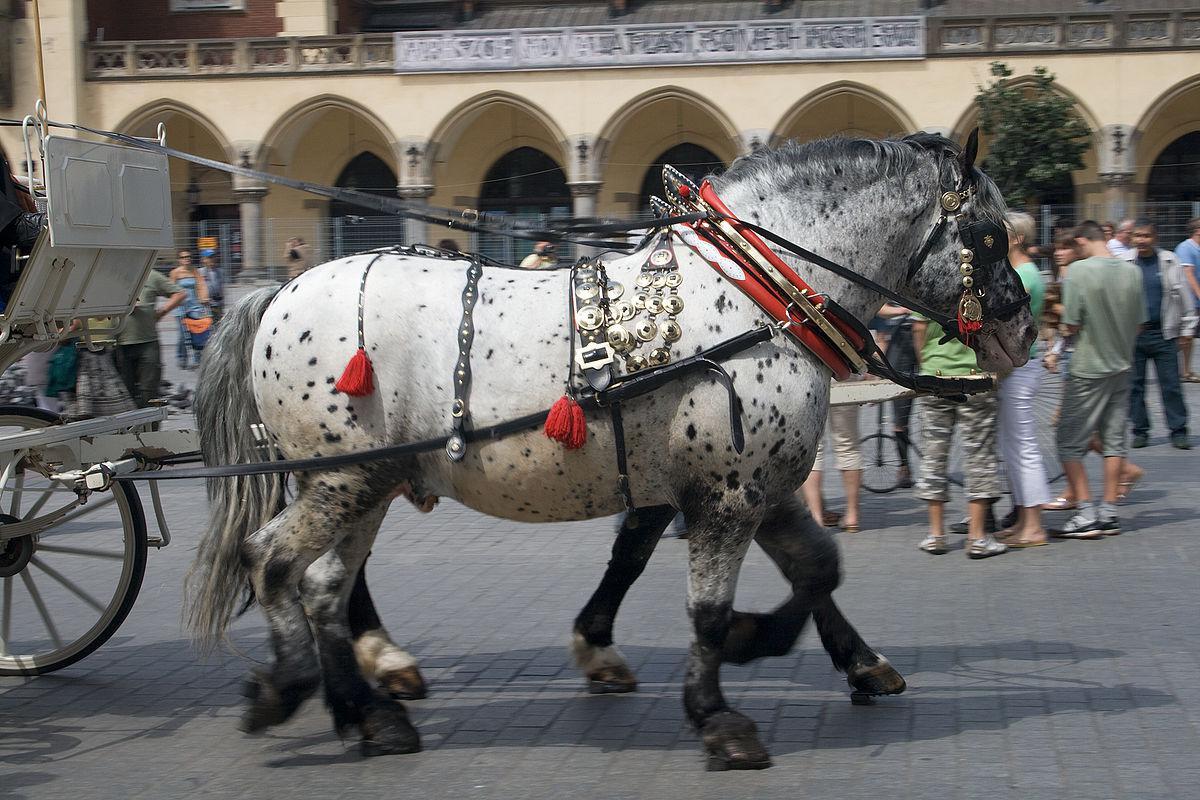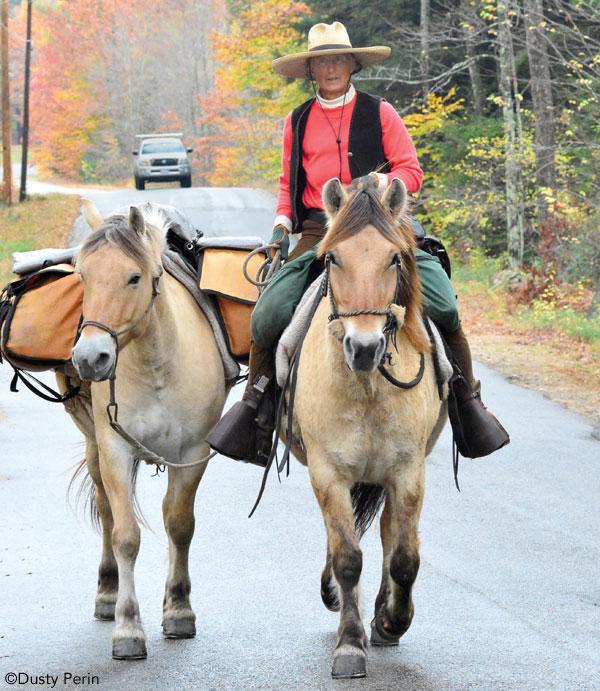The first image is the image on the left, the second image is the image on the right. Given the left and right images, does the statement "In one image, there are a pair of horses drawing a carriage holding one person to the left." hold true? Answer yes or no. No. The first image is the image on the left, the second image is the image on the right. For the images shown, is this caption "At least one of the horses is white." true? Answer yes or no. Yes. 